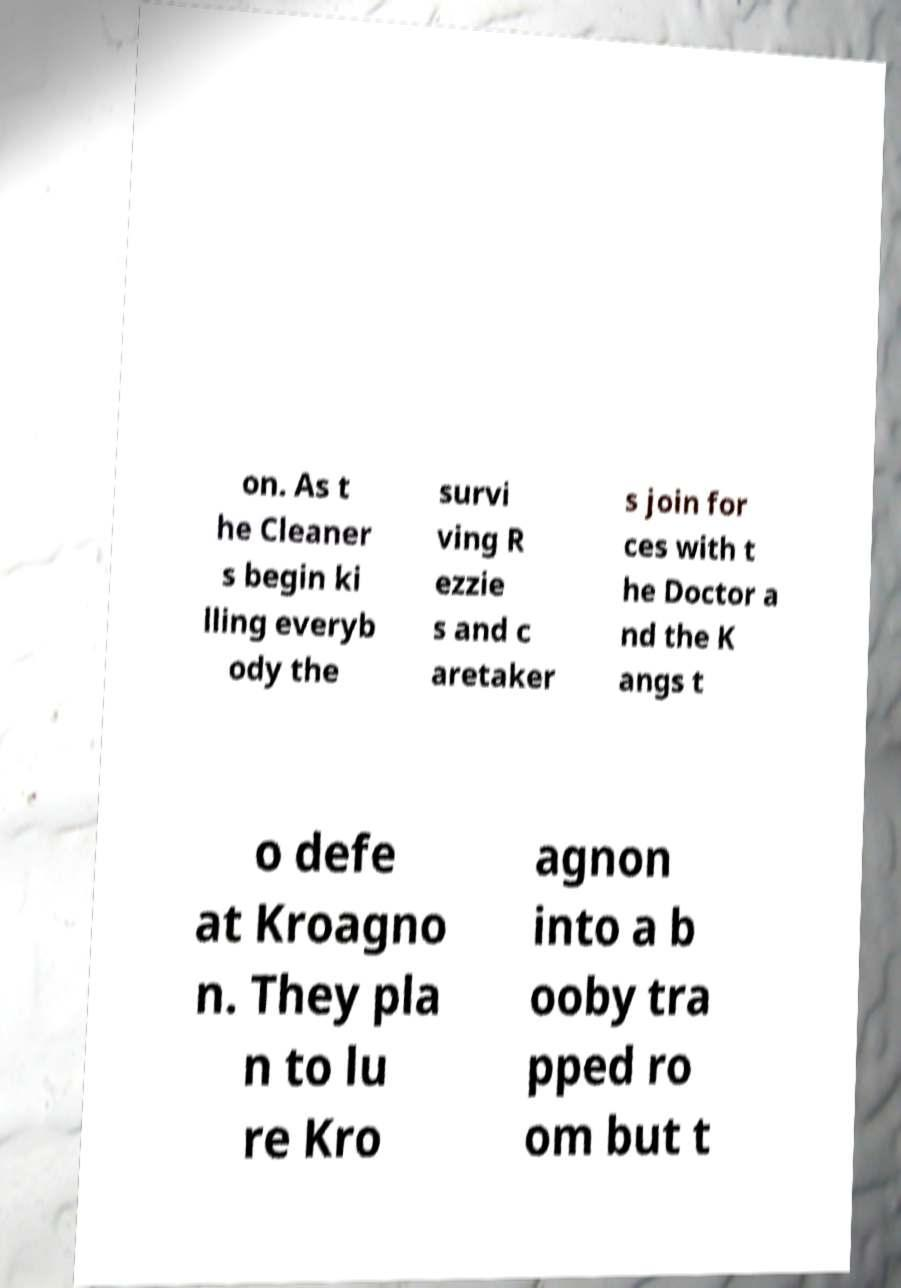I need the written content from this picture converted into text. Can you do that? on. As t he Cleaner s begin ki lling everyb ody the survi ving R ezzie s and c aretaker s join for ces with t he Doctor a nd the K angs t o defe at Kroagno n. They pla n to lu re Kro agnon into a b ooby tra pped ro om but t 